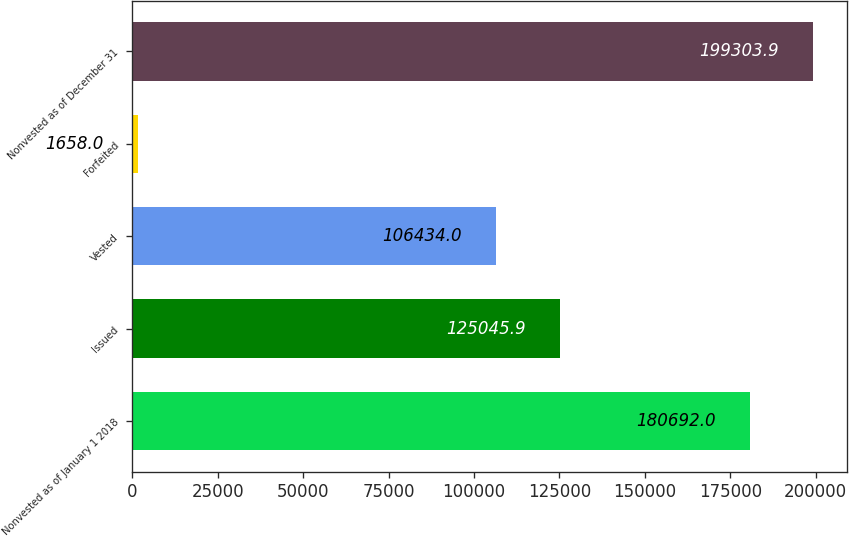Convert chart to OTSL. <chart><loc_0><loc_0><loc_500><loc_500><bar_chart><fcel>Nonvested as of January 1 2018<fcel>Issued<fcel>Vested<fcel>Forfeited<fcel>Nonvested as of December 31<nl><fcel>180692<fcel>125046<fcel>106434<fcel>1658<fcel>199304<nl></chart> 